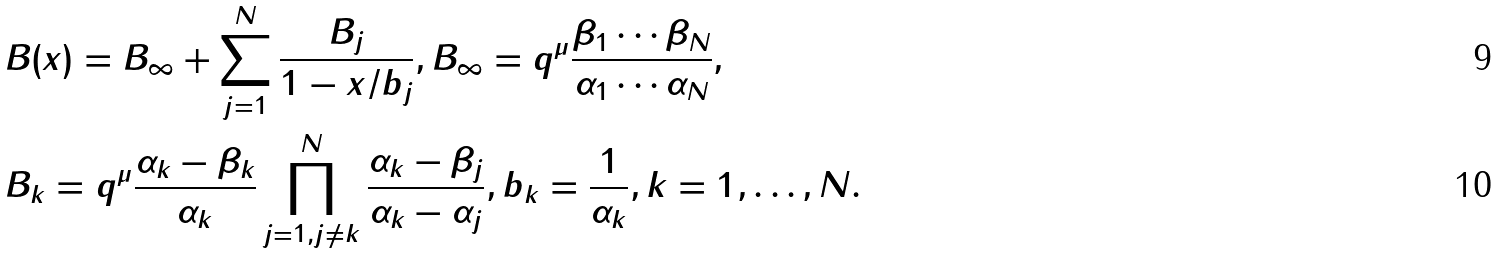Convert formula to latex. <formula><loc_0><loc_0><loc_500><loc_500>& B ( x ) = B _ { \infty } + \sum _ { j = 1 } ^ { N } \frac { B _ { j } } { 1 - x / b _ { j } } , B _ { \infty } = q ^ { \mu } \frac { \beta _ { 1 } \cdots \beta _ { N } } { \alpha _ { 1 } \cdots \alpha _ { N } } , \\ & B _ { k } = q ^ { \mu } \frac { \alpha _ { k } - \beta _ { k } } { \alpha _ { k } } \prod _ { j = 1 , j \neq k } ^ { N } \frac { \alpha _ { k } - \beta _ { j } } { \alpha _ { k } - \alpha _ { j } } , b _ { k } = \frac { 1 } { \alpha _ { k } } , k = 1 , \dots , N .</formula> 